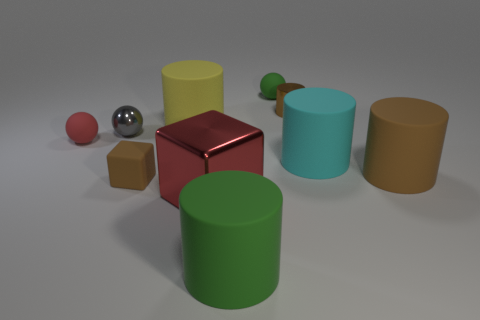Is there any other thing that has the same color as the big cube?
Keep it short and to the point. Yes. What number of green balls are there?
Provide a short and direct response. 1. What is the material of the red object that is behind the brown cylinder in front of the large cyan rubber object?
Keep it short and to the point. Rubber. There is a big matte object that is behind the sphere that is in front of the small metallic object on the left side of the big metallic cube; what color is it?
Give a very brief answer. Yellow. Does the large block have the same color as the metal ball?
Offer a very short reply. No. How many red matte spheres are the same size as the brown metal cylinder?
Give a very brief answer. 1. Is the number of red cubes right of the large brown matte object greater than the number of rubber blocks behind the small red thing?
Offer a terse response. No. What is the color of the big cylinder that is on the left side of the green thing that is in front of the tiny brown cylinder?
Give a very brief answer. Yellow. Is the material of the small gray sphere the same as the brown block?
Provide a succinct answer. No. Are there any yellow matte objects of the same shape as the gray thing?
Your answer should be compact. No. 